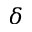<formula> <loc_0><loc_0><loc_500><loc_500>\delta</formula> 